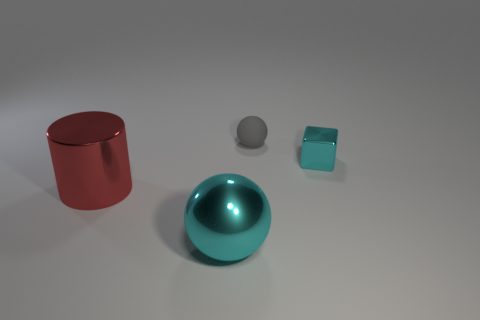Add 1 purple shiny blocks. How many objects exist? 5 Subtract all cyan balls. How many balls are left? 1 Subtract all gray cylinders. How many cyan spheres are left? 1 Subtract all large spheres. Subtract all tiny yellow metallic balls. How many objects are left? 3 Add 4 small cyan metal blocks. How many small cyan metal blocks are left? 5 Add 1 small green balls. How many small green balls exist? 1 Subtract 0 green cylinders. How many objects are left? 4 Subtract all cylinders. How many objects are left? 3 Subtract 1 blocks. How many blocks are left? 0 Subtract all purple balls. Subtract all brown blocks. How many balls are left? 2 